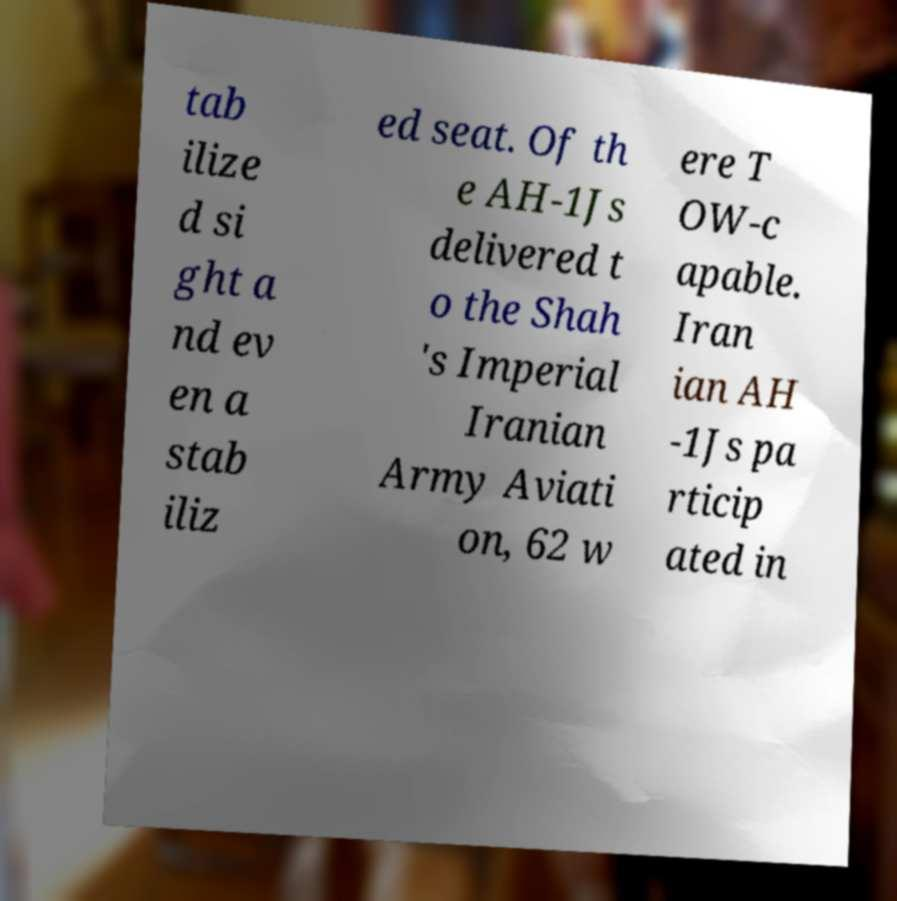There's text embedded in this image that I need extracted. Can you transcribe it verbatim? tab ilize d si ght a nd ev en a stab iliz ed seat. Of th e AH-1Js delivered t o the Shah 's Imperial Iranian Army Aviati on, 62 w ere T OW-c apable. Iran ian AH -1Js pa rticip ated in 